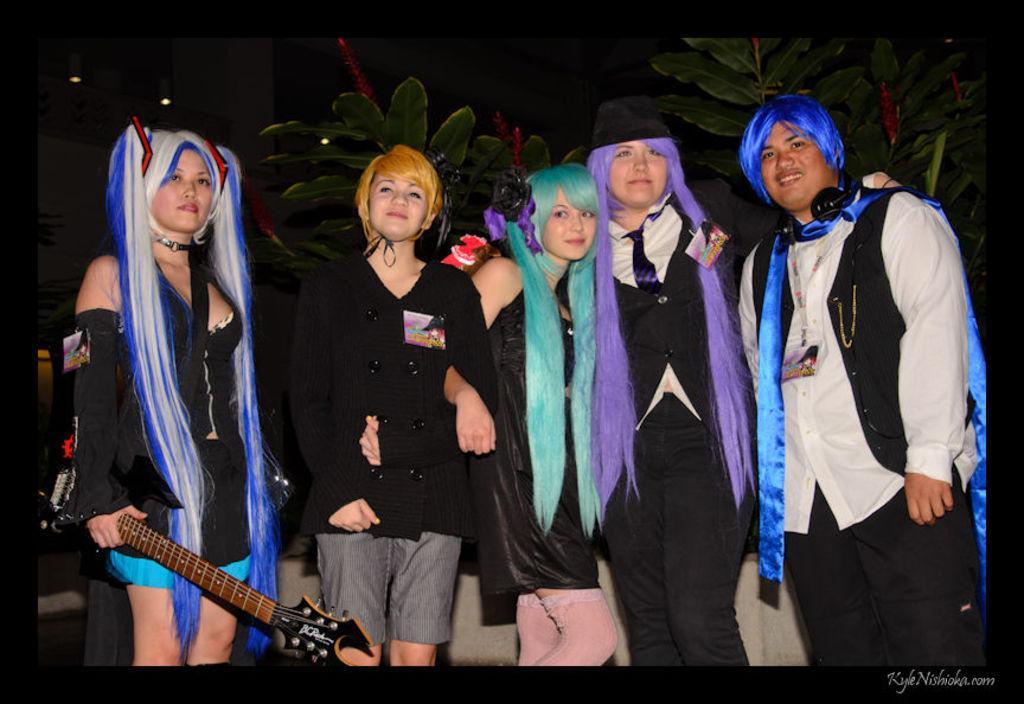Describe this image in one or two sentences. In this image i can see a group of people are standing and smiling. I can see a woman on the left side is holding a guitar. 